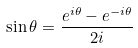<formula> <loc_0><loc_0><loc_500><loc_500>\sin \theta = \frac { e ^ { i \theta } - e ^ { - i \theta } } { 2 i }</formula> 